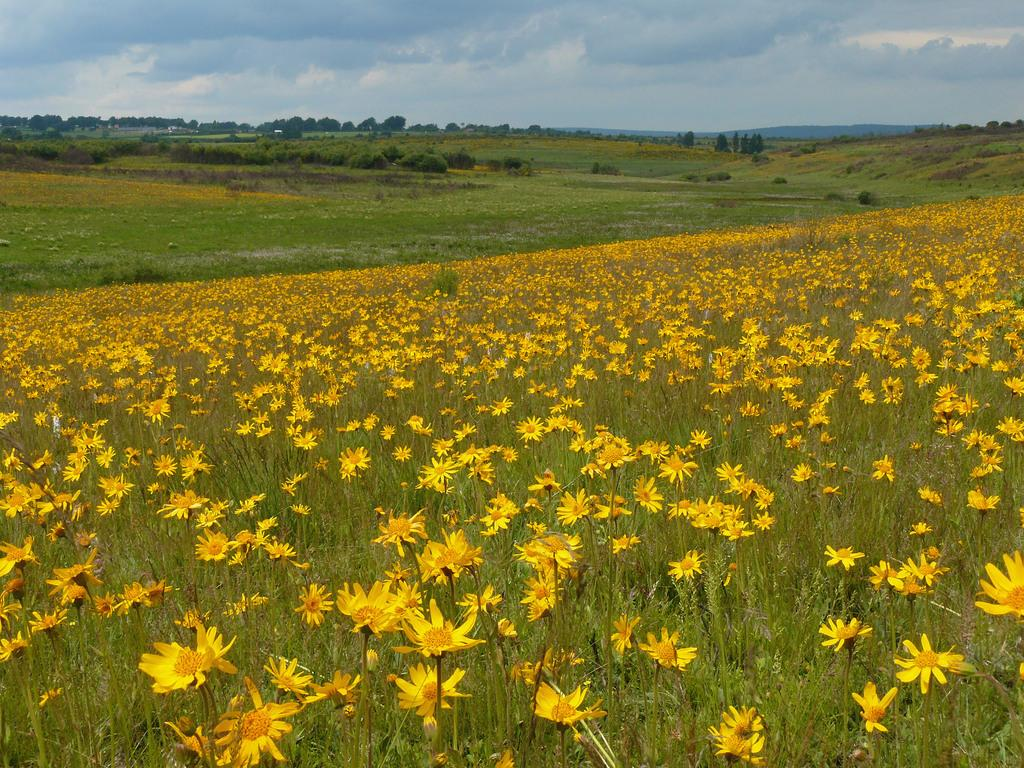What types of vegetation can be seen in the image? There are many plants and flowers in the image. Can you describe the background of the image? The background of the image includes plants, trees, a hill, and a cloudy sky. How many types of vegetation can be seen in the background? There are two types of vegetation in the background: plants and trees. Reasoning: Let' Let's think step by step in order to produce the conversation. We start by identifying the main subject of the image, which is the vegetation. Then, we describe the specific types of vegetation present, including plants and flowers. Next, we expand the conversation to include the background of the image, mentioning the presence of plants, trees, a hill, and a cloudy sky. Finally, we count the types of vegetation in the background to provide a more detailed description. Absurd Question/Answer: What type of cheese is being used to stamp the science book in the image? There is no cheese or science book present in the image; it features plants, flowers, and a background with trees, a hill, and a cloudy sky. 